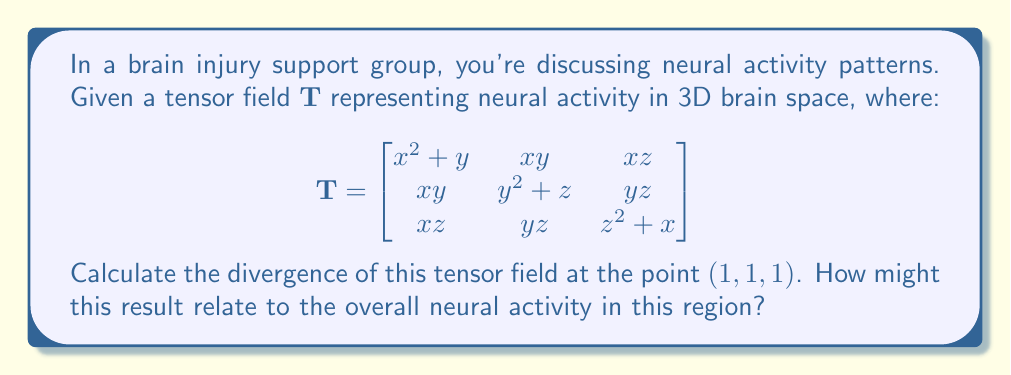Can you solve this math problem? To calculate the divergence of a tensor field, we need to sum the partial derivatives of the diagonal elements with respect to their corresponding variables. The divergence is given by:

$$\text{div}(\mathbf{T}) = \frac{\partial T_{xx}}{\partial x} + \frac{\partial T_{yy}}{\partial y} + \frac{\partial T_{zz}}{\partial z}$$

Let's calculate each term:

1) $\frac{\partial T_{xx}}{\partial x} = \frac{\partial}{\partial x}(x^2 + y) = 2x$

2) $\frac{\partial T_{yy}}{\partial y} = \frac{\partial}{\partial y}(y^2 + z) = 2y$

3) $\frac{\partial T_{zz}}{\partial z} = \frac{\partial}{\partial z}(z^2 + x) = 2z$

Now, we sum these terms:

$$\text{div}(\mathbf{T}) = 2x + 2y + 2z$$

At the point $(1, 1, 1)$:

$$\text{div}(\mathbf{T}) = 2(1) + 2(1) + 2(1) = 6$$

This result indicates a positive divergence, suggesting an outward flow or expansion of neural activity at this point. In the context of brain injury support, this could represent increased neural activation in this region, possibly related to compensatory mechanisms or neuroplasticity following injury.
Answer: $6$ 